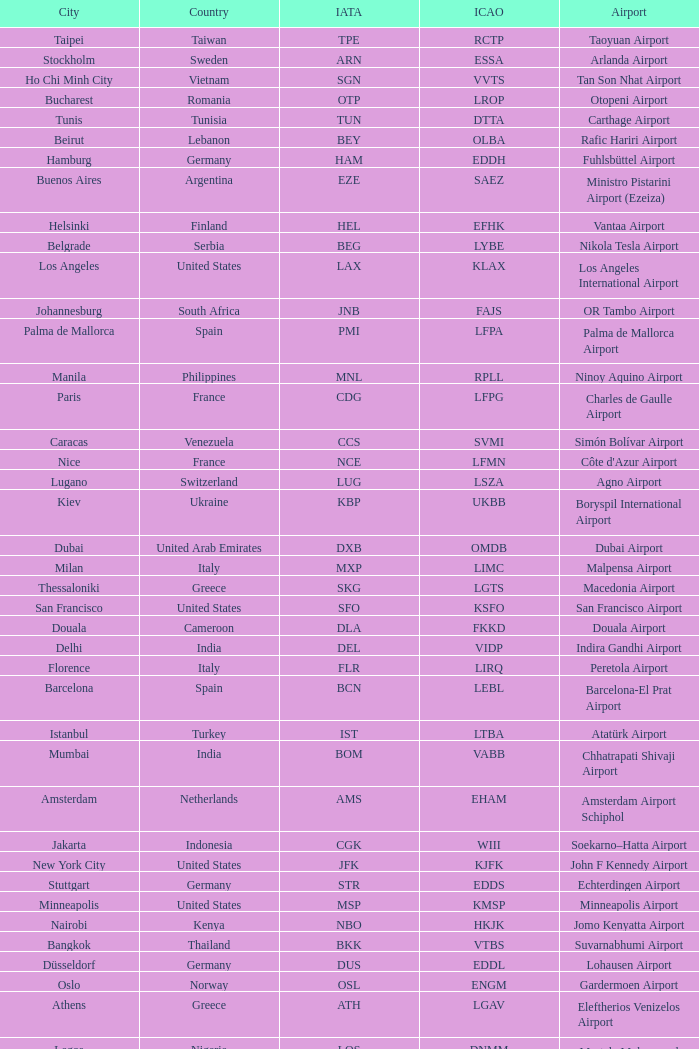What is the ICAO of Lohausen airport? EDDL. 